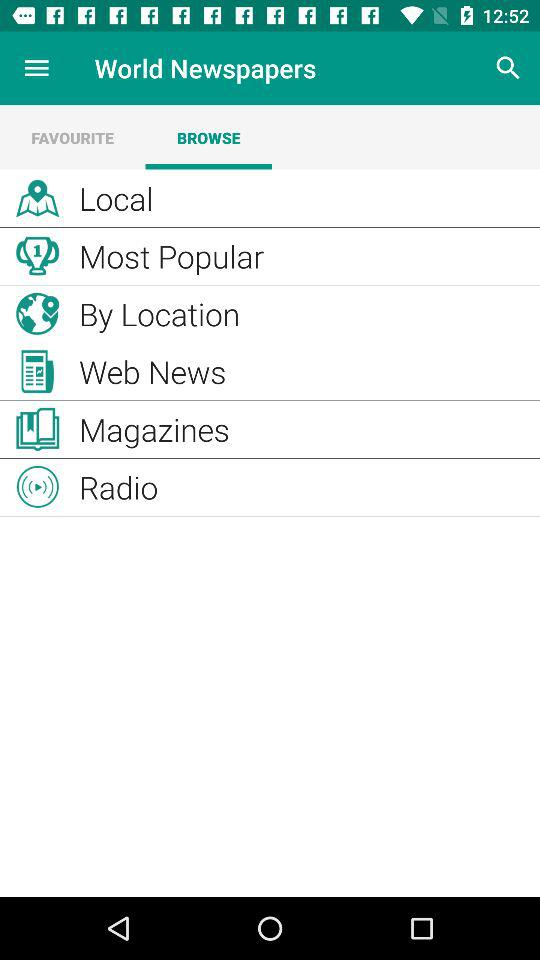Which tab is selected? The selected tab is "BROWSE". 